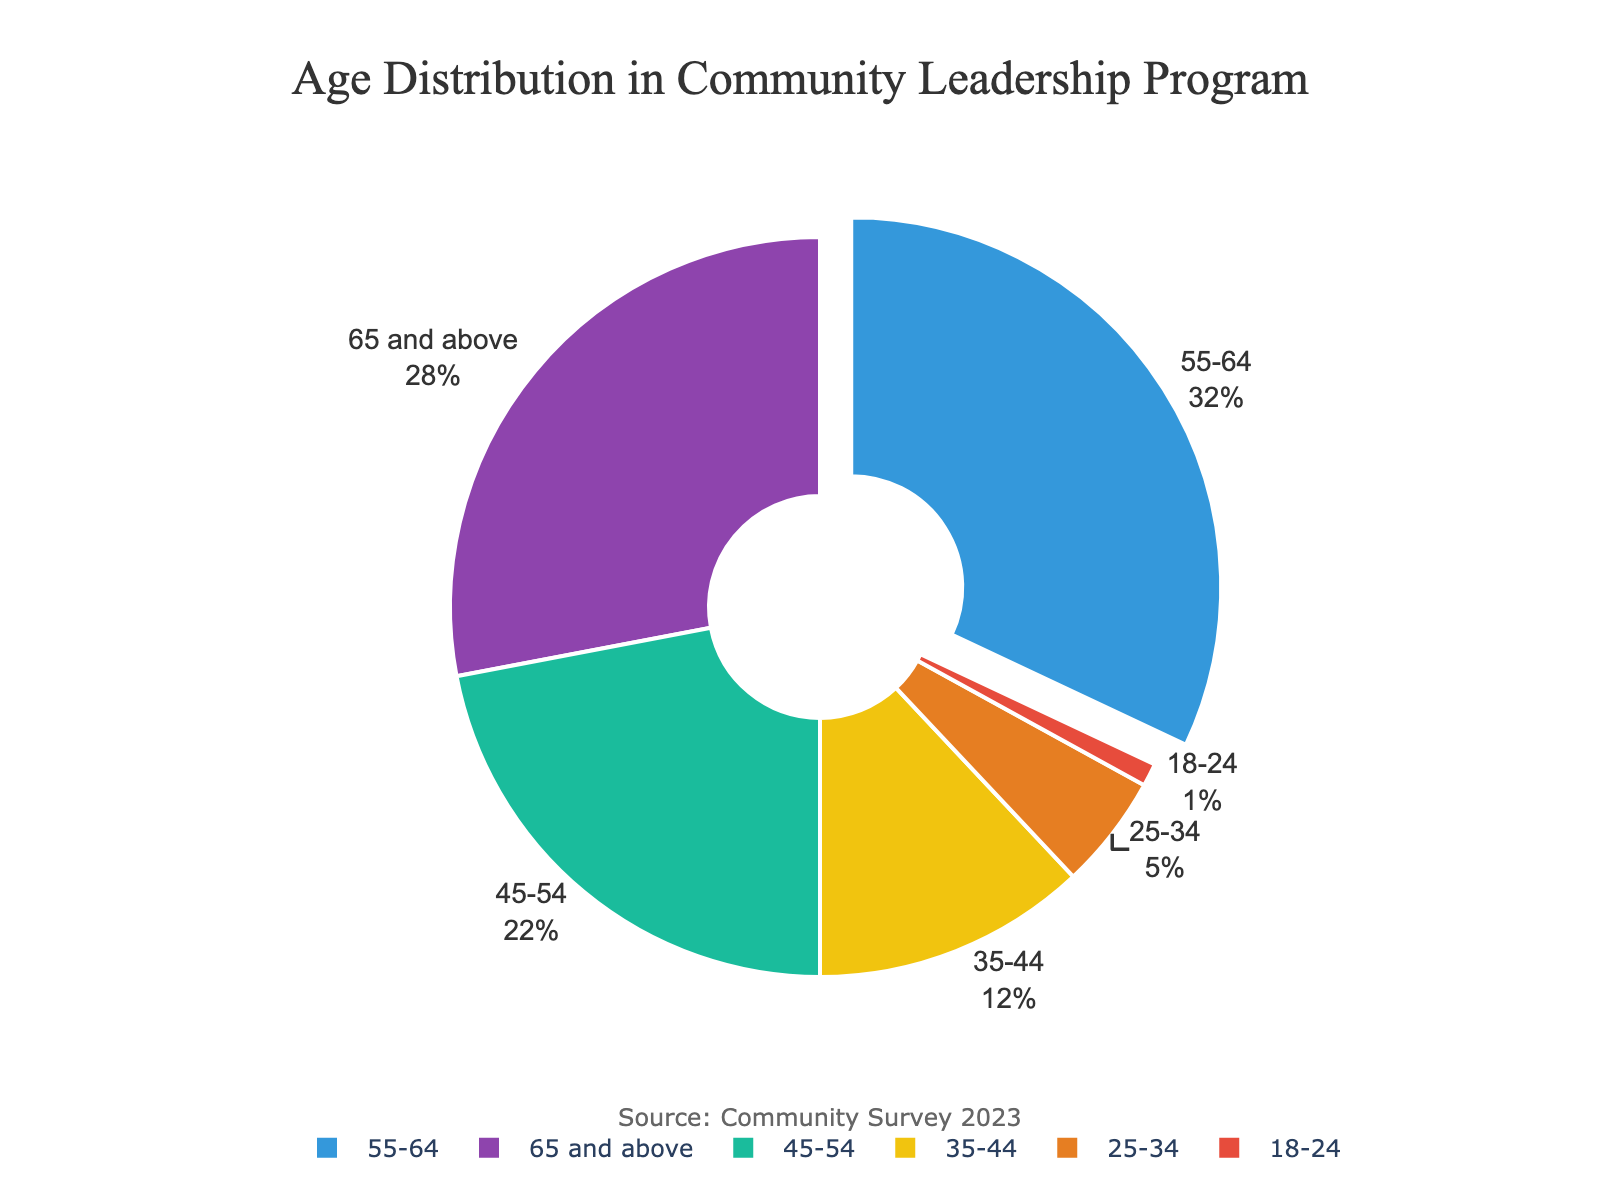What's the largest age group in the community leadership program and what percentage do they represent? The figure highlights the "55-64" age group as the largest by pulling this segment slightly out. This group represents 32% of the total participants.
Answer: 55-64, 32% What's the combined percentage of participants who are 45 and older? Sum up the percentages for "45-54", "55-64", and "65 and above". This is 22% + 32% + 28% = 82%.
Answer: 82% Which age group has the lowest representation, and what is their percentage? The smallest segment by visual size and percentage is the "18-24" age group, representing 1% of the participants.
Answer: 18-24, 1% How does the proportion of participants aged 35-44 compare to those aged 45-54? The "35-44" age group represents 12%, while the "45-54" group represents 22%. Therefore, the 35-44 group is 10% less than the 45-54 group.
Answer: 10% less What is the total percentage of participants under the age of 45? Combine the percentages for "18-24", "25-34", and "35-44". This is 1% + 5% + 12% = 18%.
Answer: 18% How much larger is the 55-64 age group compared to the 35-44 age group? The percentage for the "55-64" group is 32%, and for the "35-44" group, it is 12%. Subtracting, we get 32% - 12% = 20%.
Answer: 20% Which color represents the 65 and above age group, and what is their percentage? The "65 and above" age group is represented by the first color in the palette, which is purple, and they make up 28% of the participants.
Answer: purple, 28% What is the average percentage of the age groups under 35 years old? Add the percentages for "18-24" and "25-34", which is 1% + 5% = 6%. There are 2 groups, so the average percentage is 6% / 2 = 3%.
Answer: 3% What's the difference in percentage between the 55-64 and 65 and above age groups? The "55-64" age group has 32%, and the "65 and above" group has 28%. The difference is 32% - 28% = 4%.
Answer: 4% How do the combined percentages of participants aged 25-44 compare to those aged 45-64? The combined percentage for "25-34" and "35-44" is 5% + 12% = 17%. The combined percentage for "45-54" and "55-64" is 22% + 32% = 54%. The difference is 54% - 17% = 37%.
Answer: 37% 